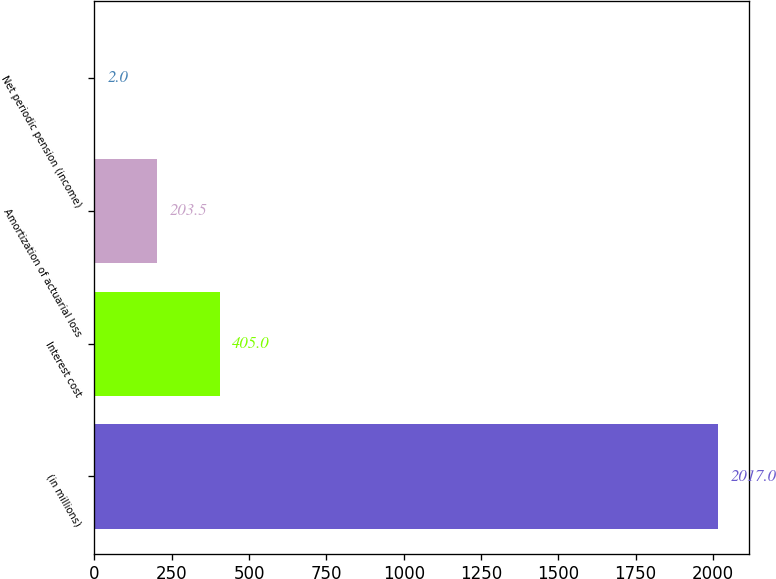Convert chart. <chart><loc_0><loc_0><loc_500><loc_500><bar_chart><fcel>(in millions)<fcel>Interest cost<fcel>Amortization of actuarial loss<fcel>Net periodic pension (income)<nl><fcel>2017<fcel>405<fcel>203.5<fcel>2<nl></chart> 